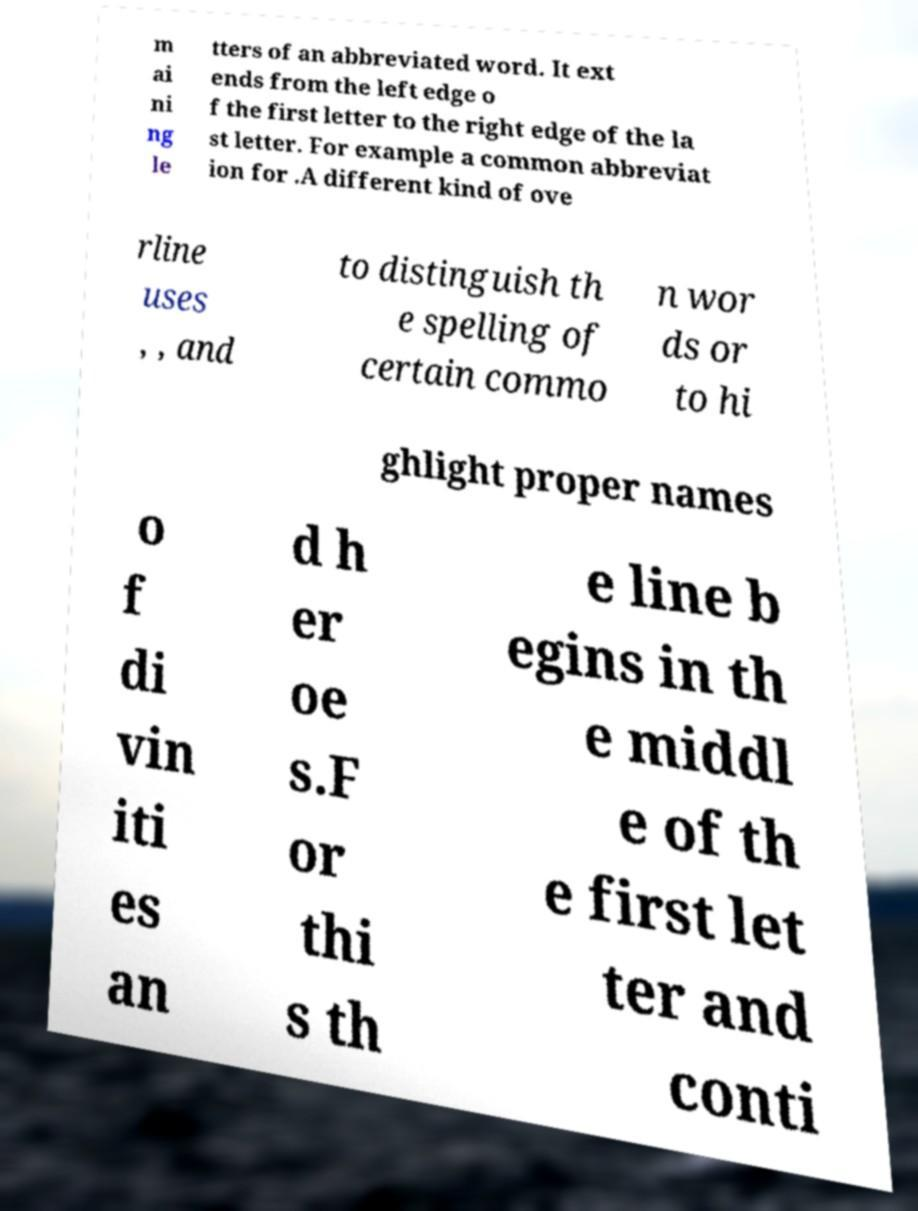Could you assist in decoding the text presented in this image and type it out clearly? m ai ni ng le tters of an abbreviated word. It ext ends from the left edge o f the first letter to the right edge of the la st letter. For example a common abbreviat ion for .A different kind of ove rline uses , , and to distinguish th e spelling of certain commo n wor ds or to hi ghlight proper names o f di vin iti es an d h er oe s.F or thi s th e line b egins in th e middl e of th e first let ter and conti 